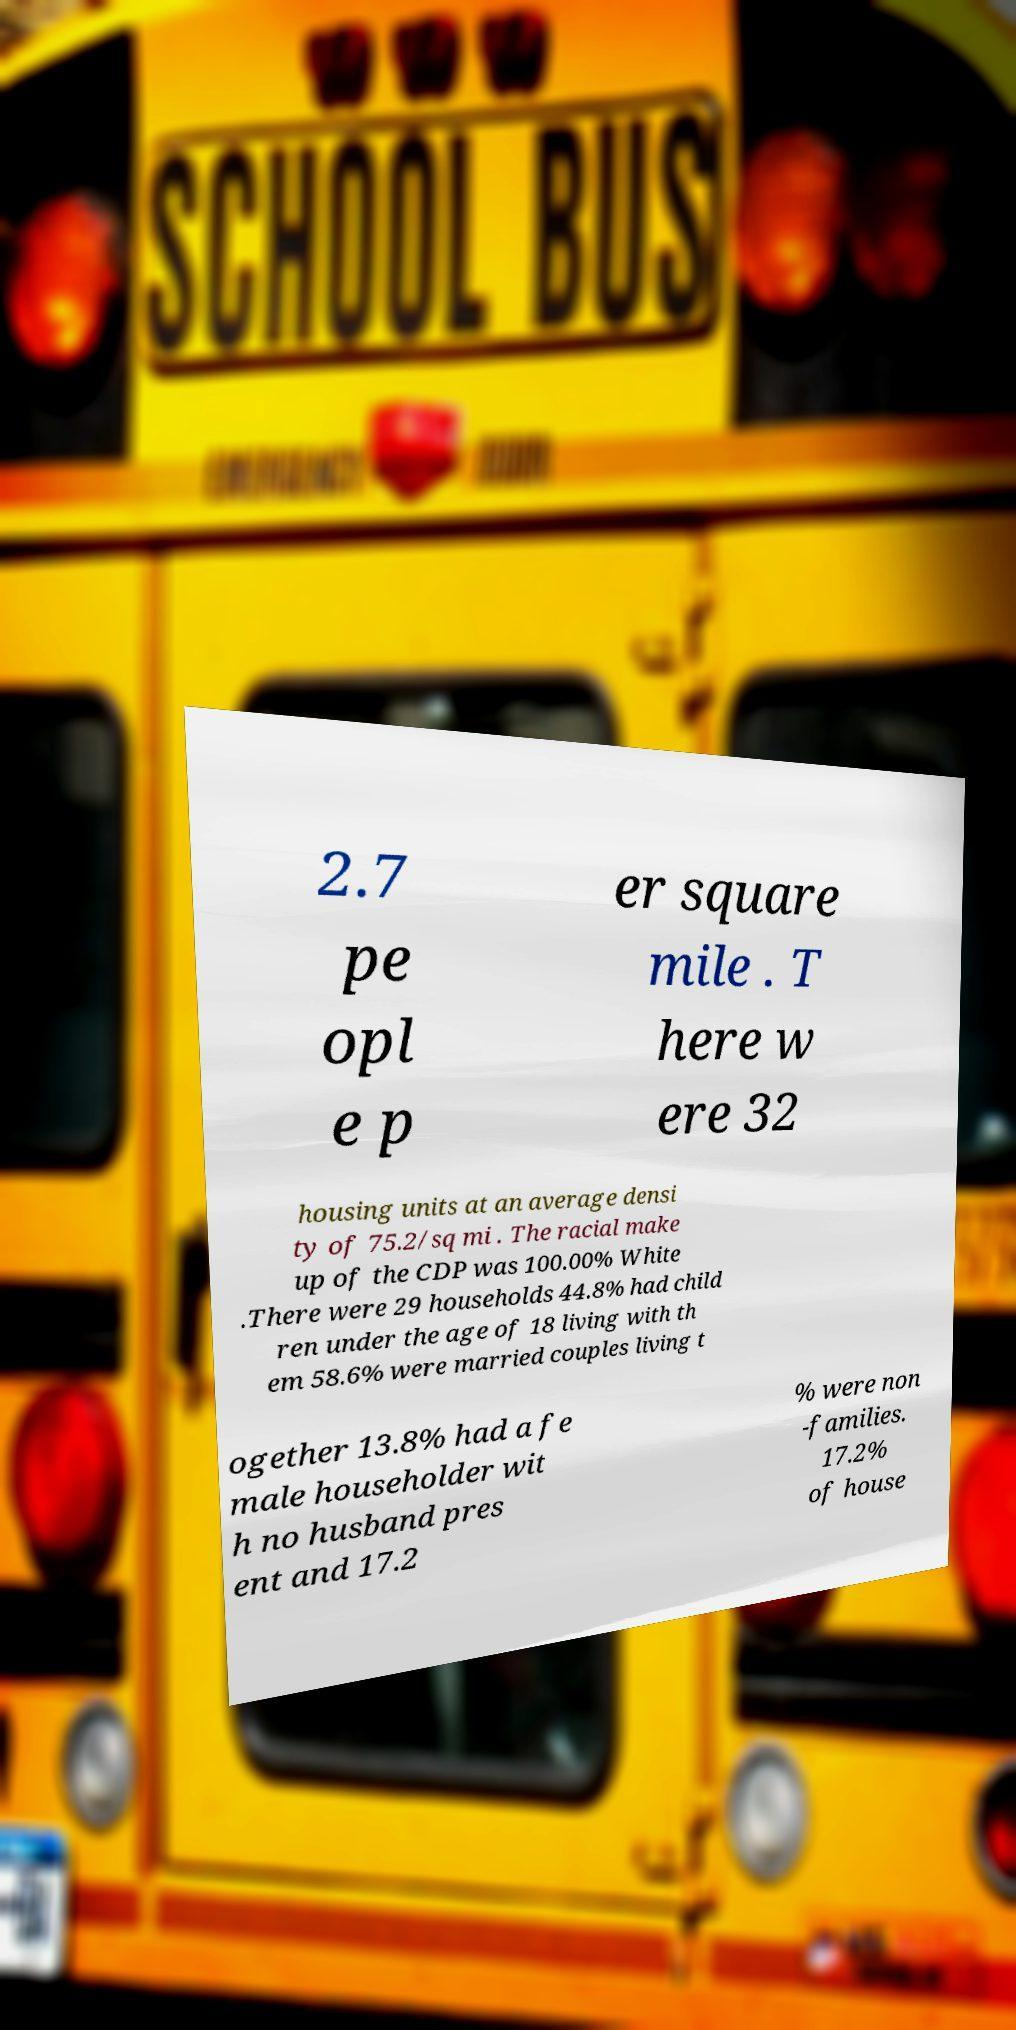Could you assist in decoding the text presented in this image and type it out clearly? 2.7 pe opl e p er square mile . T here w ere 32 housing units at an average densi ty of 75.2/sq mi . The racial make up of the CDP was 100.00% White .There were 29 households 44.8% had child ren under the age of 18 living with th em 58.6% were married couples living t ogether 13.8% had a fe male householder wit h no husband pres ent and 17.2 % were non -families. 17.2% of house 